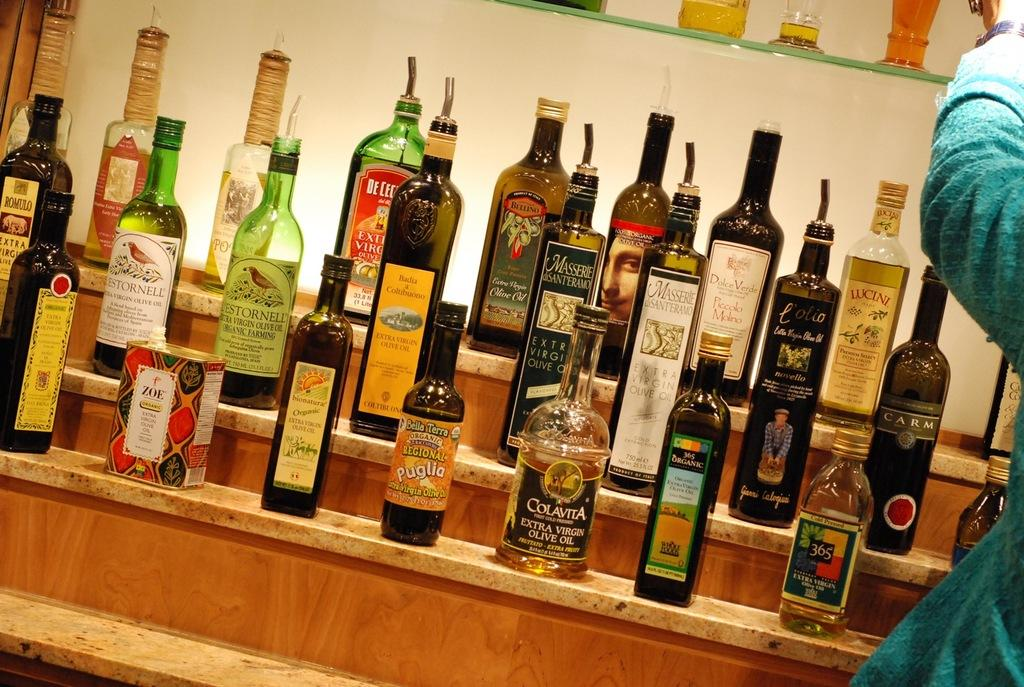Provide a one-sentence caption for the provided image. wooden shelves with bottles of olive oil such as 365 organic, colavita, bella terra, etc. 